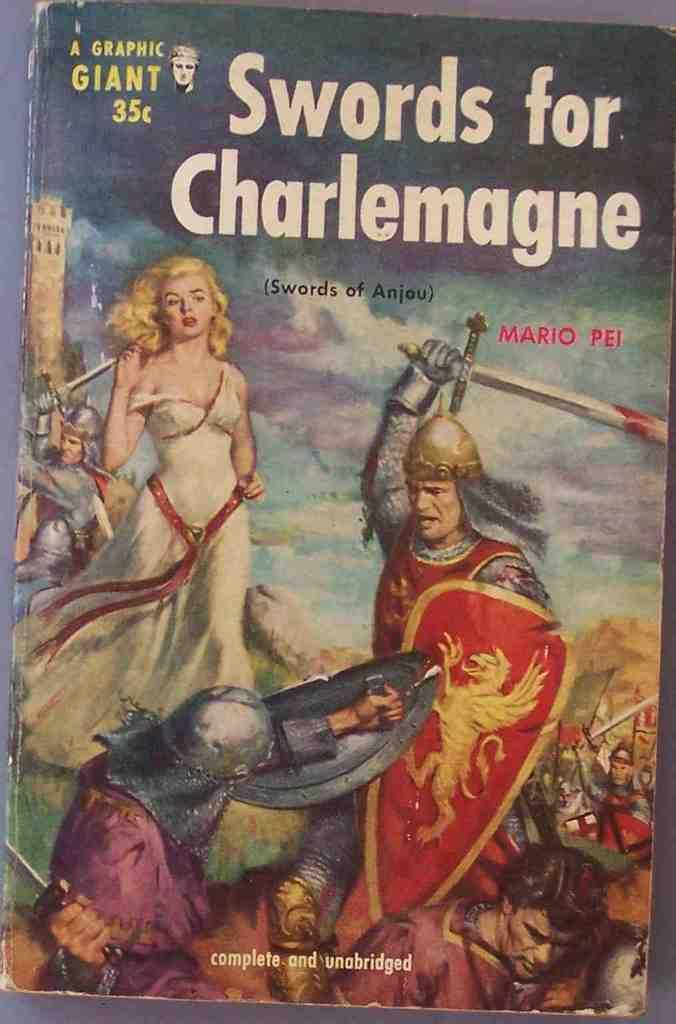Provide a one-sentence caption for the provided image. The book, Swords for Charlemagne, has a cover that makes it look old. 